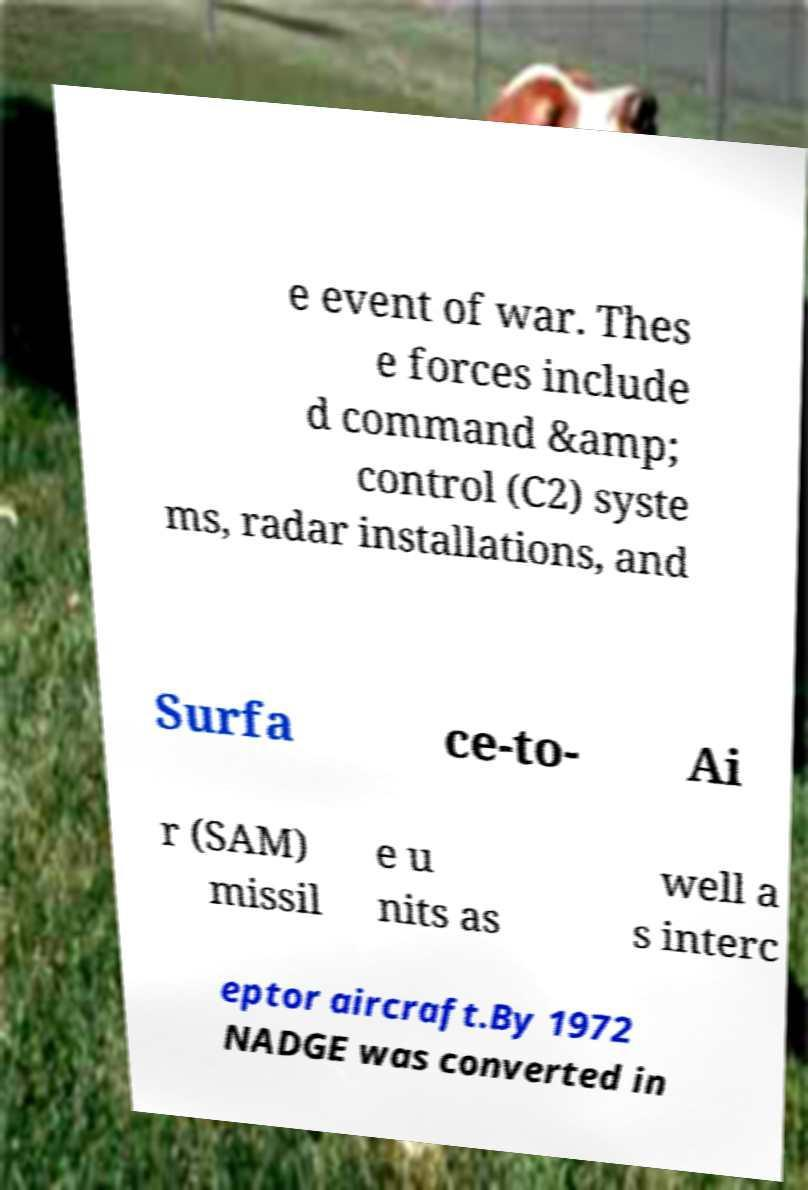What messages or text are displayed in this image? I need them in a readable, typed format. e event of war. Thes e forces include d command &amp; control (C2) syste ms, radar installations, and Surfa ce-to- Ai r (SAM) missil e u nits as well a s interc eptor aircraft.By 1972 NADGE was converted in 